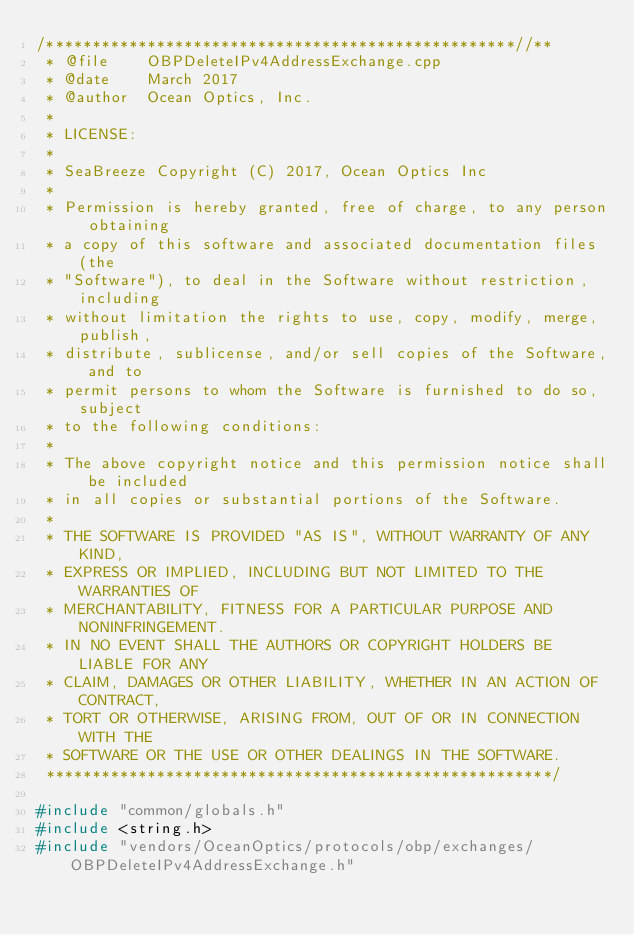Convert code to text. <code><loc_0><loc_0><loc_500><loc_500><_C++_>/***************************************************//**
 * @file    OBPDeleteIPv4AddressExchange.cpp
 * @date    March 2017
 * @author  Ocean Optics, Inc.
 *
 * LICENSE:
 *
 * SeaBreeze Copyright (C) 2017, Ocean Optics Inc
 *
 * Permission is hereby granted, free of charge, to any person obtaining
 * a copy of this software and associated documentation files (the
 * "Software"), to deal in the Software without restriction, including
 * without limitation the rights to use, copy, modify, merge, publish,
 * distribute, sublicense, and/or sell copies of the Software, and to
 * permit persons to whom the Software is furnished to do so, subject
 * to the following conditions:
 *
 * The above copyright notice and this permission notice shall be included
 * in all copies or substantial portions of the Software.
 *
 * THE SOFTWARE IS PROVIDED "AS IS", WITHOUT WARRANTY OF ANY KIND,
 * EXPRESS OR IMPLIED, INCLUDING BUT NOT LIMITED TO THE WARRANTIES OF
 * MERCHANTABILITY, FITNESS FOR A PARTICULAR PURPOSE AND NONINFRINGEMENT.
 * IN NO EVENT SHALL THE AUTHORS OR COPYRIGHT HOLDERS BE LIABLE FOR ANY
 * CLAIM, DAMAGES OR OTHER LIABILITY, WHETHER IN AN ACTION OF CONTRACT,
 * TORT OR OTHERWISE, ARISING FROM, OUT OF OR IN CONNECTION WITH THE
 * SOFTWARE OR THE USE OR OTHER DEALINGS IN THE SOFTWARE.
 *******************************************************/

#include "common/globals.h"
#include <string.h>
#include "vendors/OceanOptics/protocols/obp/exchanges/OBPDeleteIPv4AddressExchange.h"</code> 